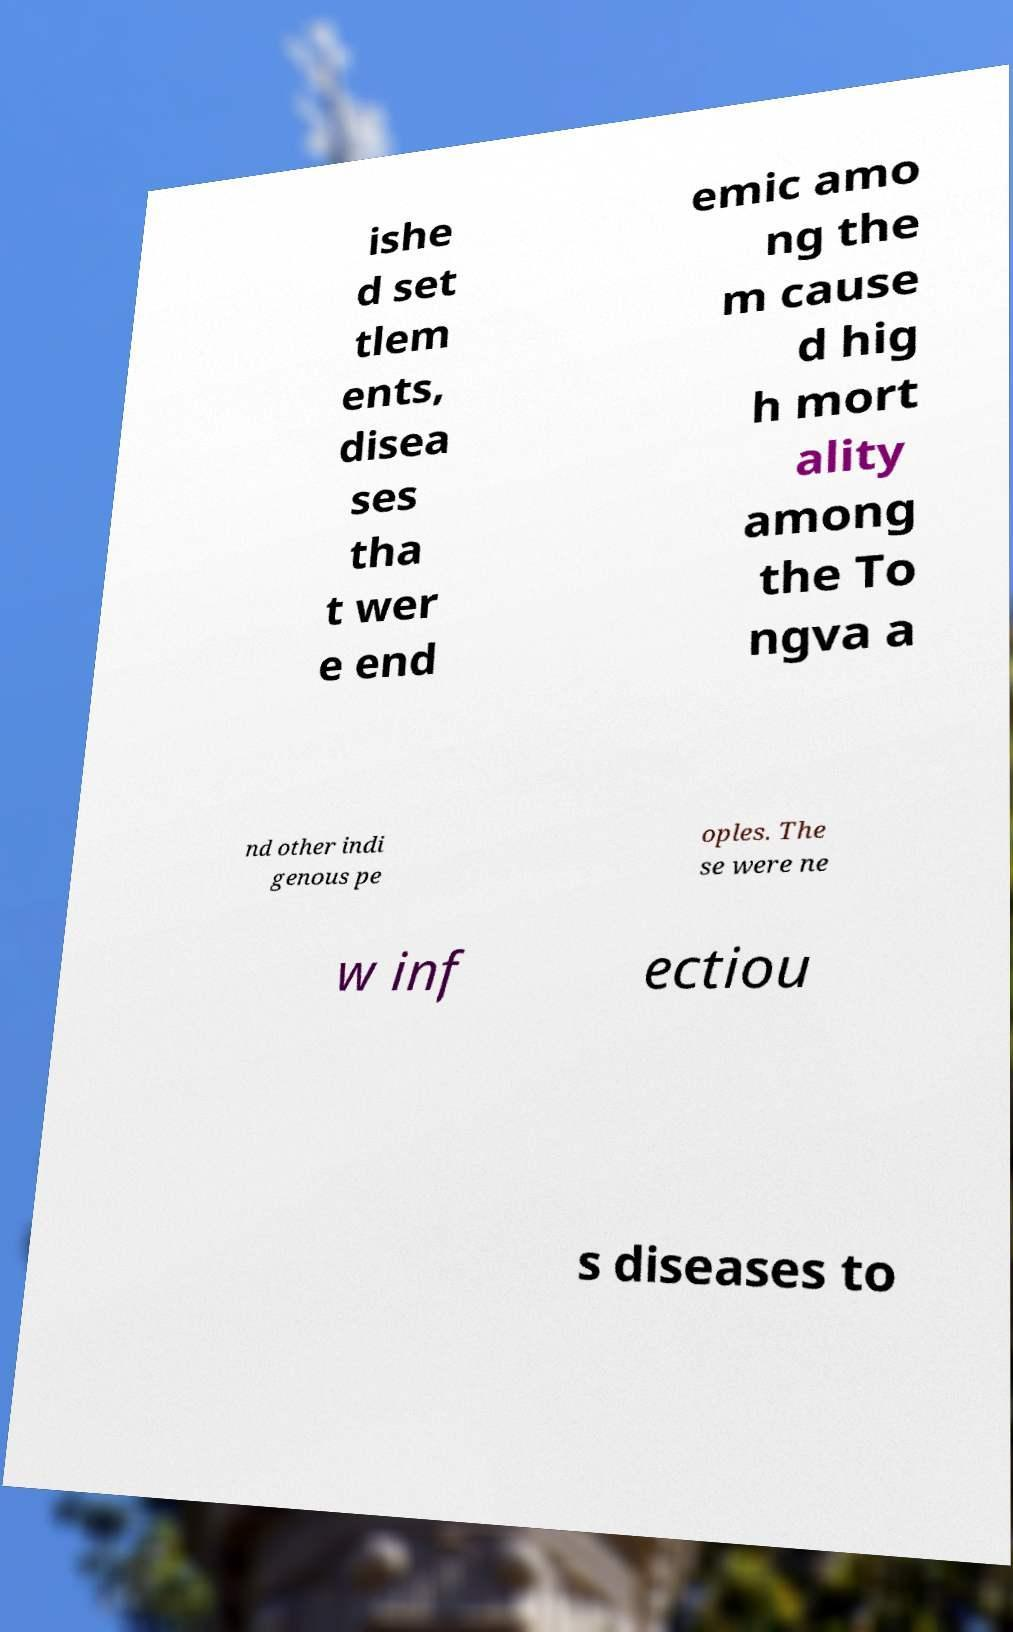What messages or text are displayed in this image? I need them in a readable, typed format. ishe d set tlem ents, disea ses tha t wer e end emic amo ng the m cause d hig h mort ality among the To ngva a nd other indi genous pe oples. The se were ne w inf ectiou s diseases to 